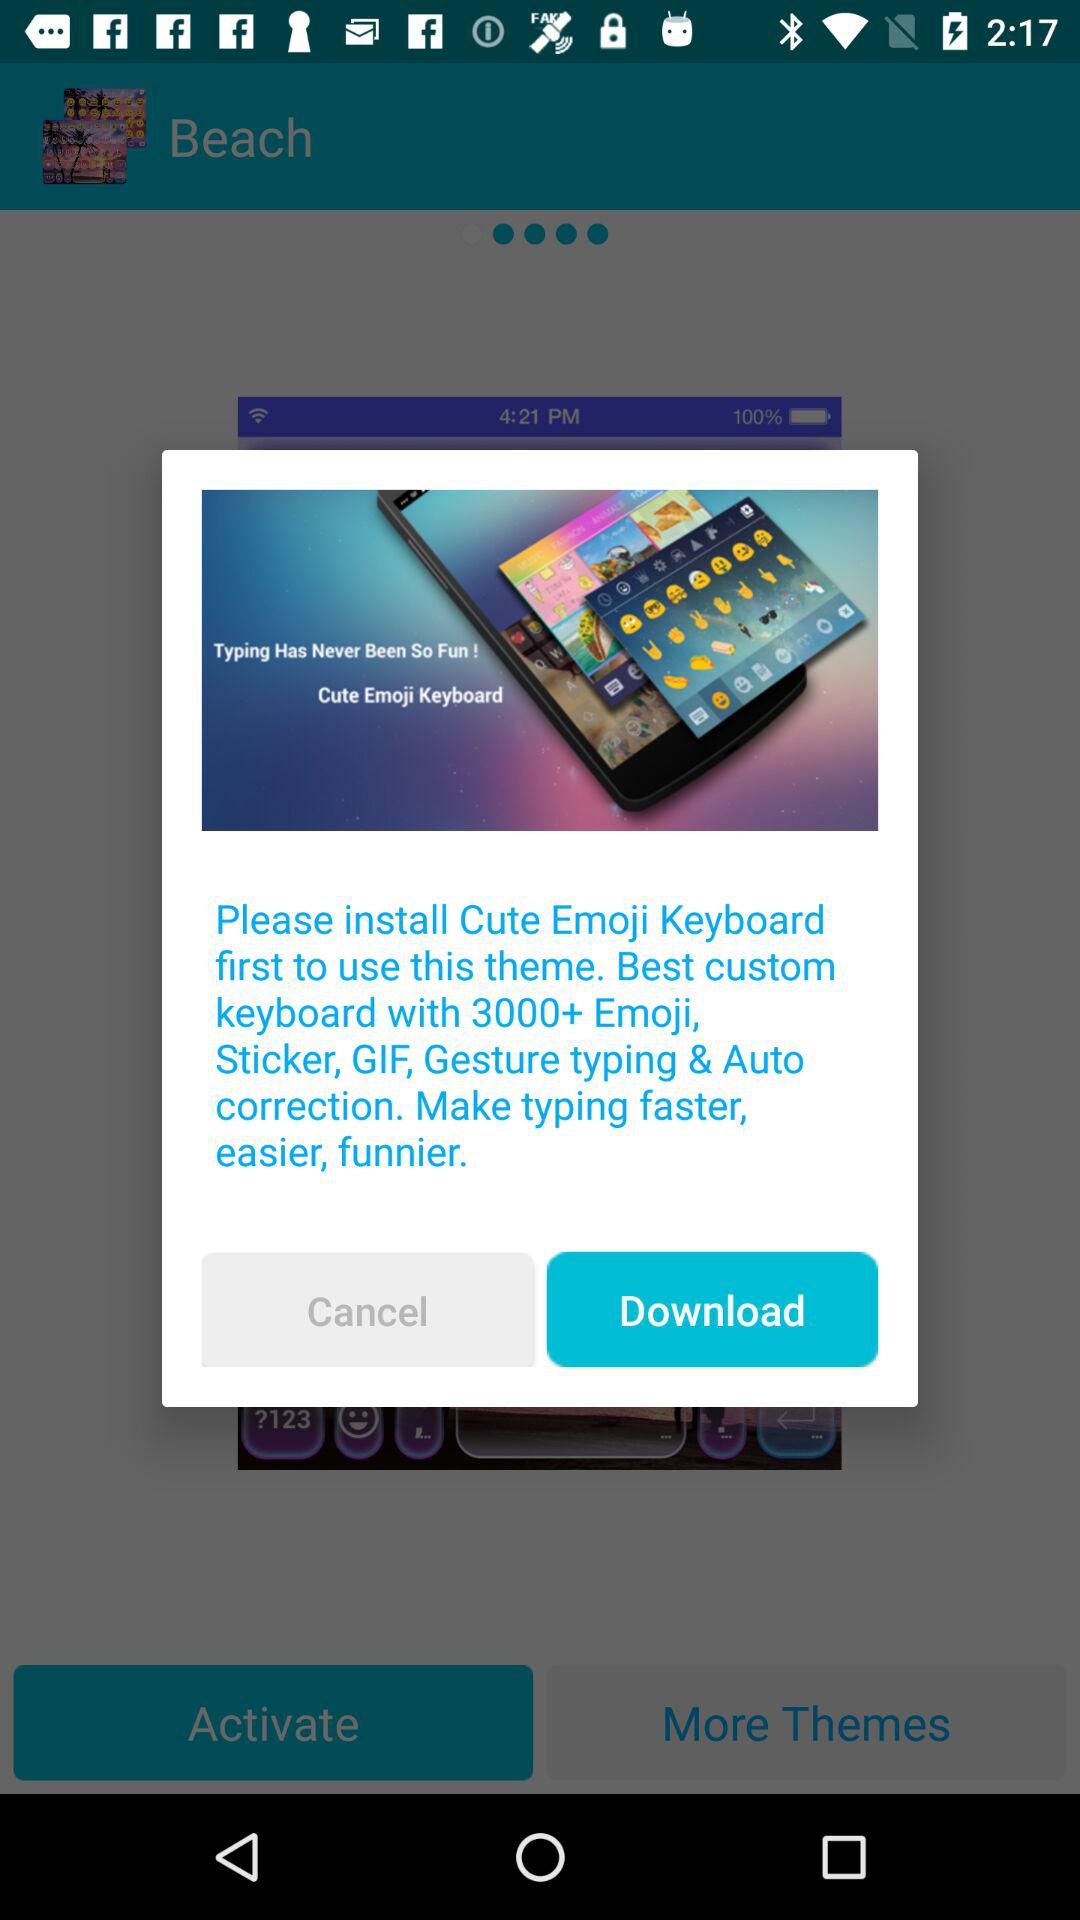What is the application name? The application name is "Cute Emoji Keyboard". 